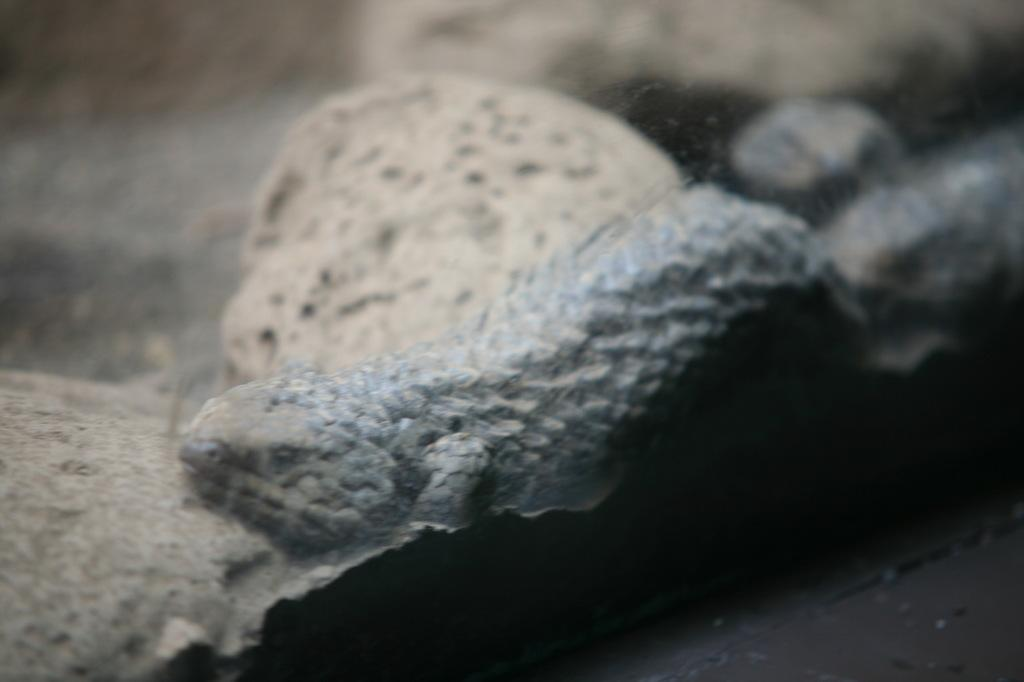What type of animal is in the image? There is a reptile in the image. Can you describe the background of the image? The background of the image is blurred. How many fingers can be seen on the reptile in the image? Reptiles do not have fingers, so there are no fingers visible on the reptile in the image. What route is the reptile taking in the image? The image does not depict the reptile taking any route, as it is a still image. 